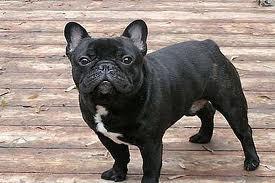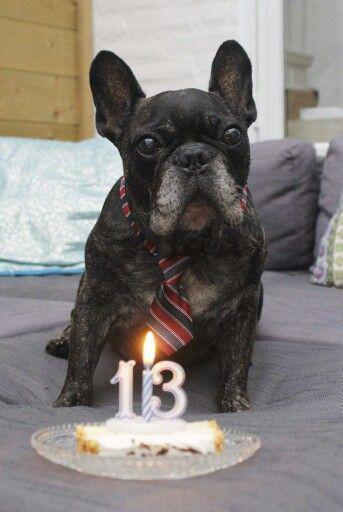The first image is the image on the left, the second image is the image on the right. Considering the images on both sides, is "The dog in the right image is wearing a human-like accessory." valid? Answer yes or no. Yes. The first image is the image on the left, the second image is the image on the right. Examine the images to the left and right. Is the description "The lefthand image contains exactly one dog, which is standing on all fours, and the right image shows one sitting dog." accurate? Answer yes or no. Yes. 